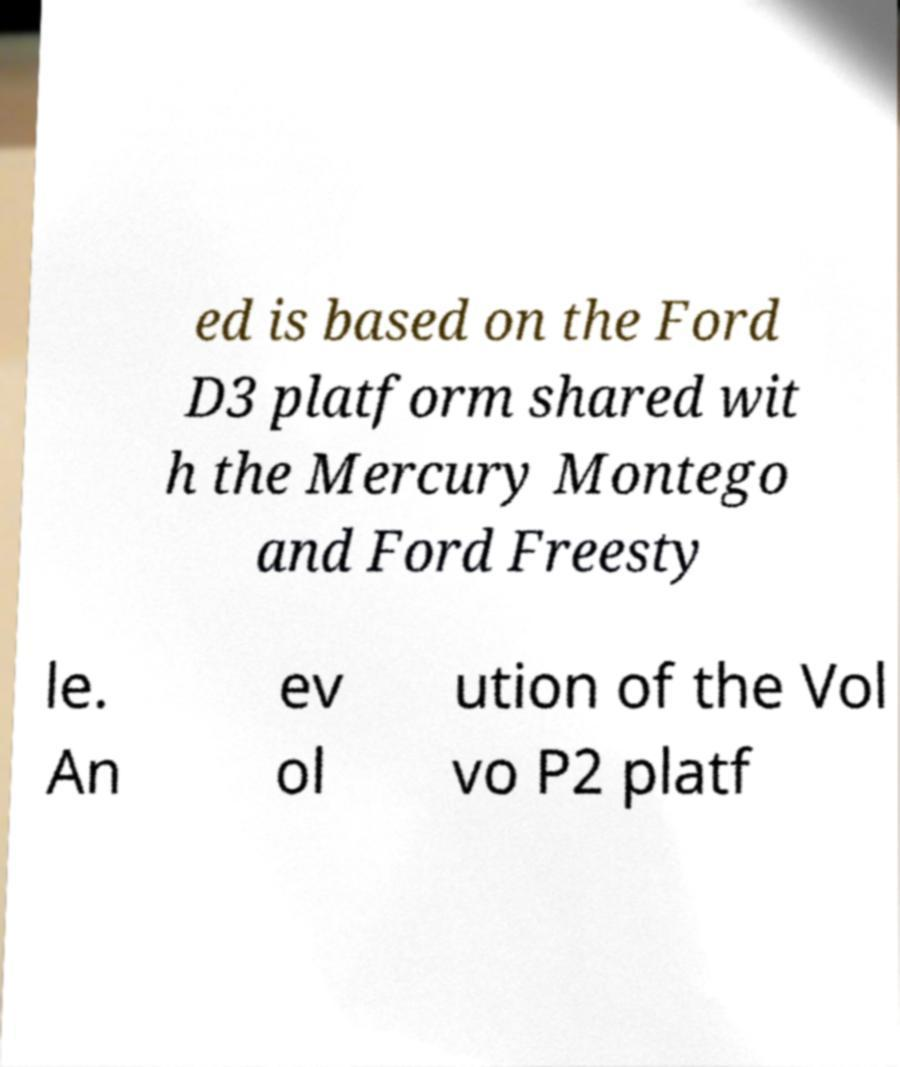For documentation purposes, I need the text within this image transcribed. Could you provide that? ed is based on the Ford D3 platform shared wit h the Mercury Montego and Ford Freesty le. An ev ol ution of the Vol vo P2 platf 